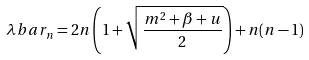<formula> <loc_0><loc_0><loc_500><loc_500>\lambda b a r _ { n } = 2 n \left ( { 1 + \sqrt { \frac { m ^ { 2 } + \beta + u } { 2 } } } \right ) + n ( n - 1 )</formula> 